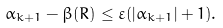<formula> <loc_0><loc_0><loc_500><loc_500>\alpha _ { k + 1 } - \beta ( R ) \leq \varepsilon ( | \alpha _ { k + 1 } | + 1 ) .</formula> 